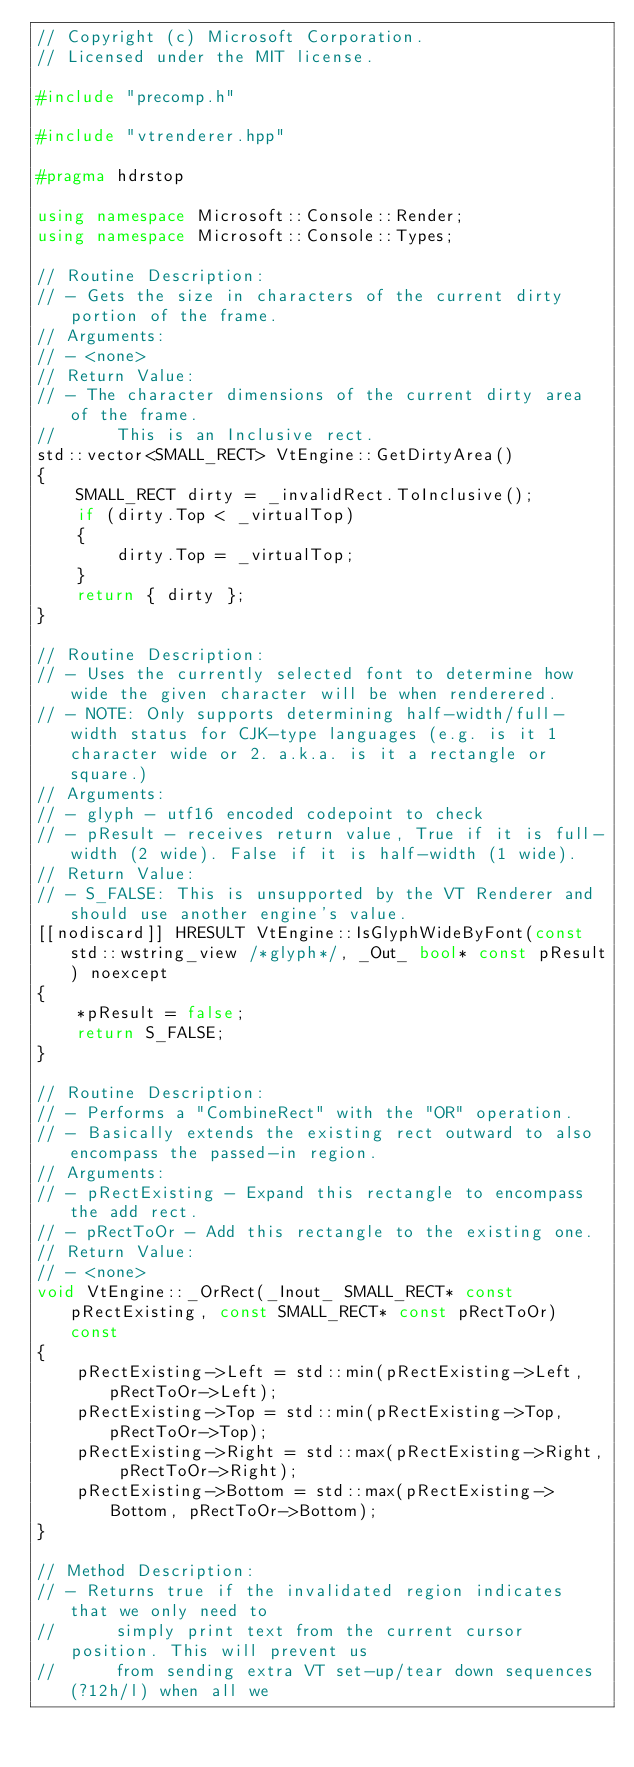<code> <loc_0><loc_0><loc_500><loc_500><_C++_>// Copyright (c) Microsoft Corporation.
// Licensed under the MIT license.

#include "precomp.h"

#include "vtrenderer.hpp"

#pragma hdrstop

using namespace Microsoft::Console::Render;
using namespace Microsoft::Console::Types;

// Routine Description:
// - Gets the size in characters of the current dirty portion of the frame.
// Arguments:
// - <none>
// Return Value:
// - The character dimensions of the current dirty area of the frame.
//      This is an Inclusive rect.
std::vector<SMALL_RECT> VtEngine::GetDirtyArea()
{
    SMALL_RECT dirty = _invalidRect.ToInclusive();
    if (dirty.Top < _virtualTop)
    {
        dirty.Top = _virtualTop;
    }
    return { dirty };
}

// Routine Description:
// - Uses the currently selected font to determine how wide the given character will be when renderered.
// - NOTE: Only supports determining half-width/full-width status for CJK-type languages (e.g. is it 1 character wide or 2. a.k.a. is it a rectangle or square.)
// Arguments:
// - glyph - utf16 encoded codepoint to check
// - pResult - receives return value, True if it is full-width (2 wide). False if it is half-width (1 wide).
// Return Value:
// - S_FALSE: This is unsupported by the VT Renderer and should use another engine's value.
[[nodiscard]] HRESULT VtEngine::IsGlyphWideByFont(const std::wstring_view /*glyph*/, _Out_ bool* const pResult) noexcept
{
    *pResult = false;
    return S_FALSE;
}

// Routine Description:
// - Performs a "CombineRect" with the "OR" operation.
// - Basically extends the existing rect outward to also encompass the passed-in region.
// Arguments:
// - pRectExisting - Expand this rectangle to encompass the add rect.
// - pRectToOr - Add this rectangle to the existing one.
// Return Value:
// - <none>
void VtEngine::_OrRect(_Inout_ SMALL_RECT* const pRectExisting, const SMALL_RECT* const pRectToOr) const
{
    pRectExisting->Left = std::min(pRectExisting->Left, pRectToOr->Left);
    pRectExisting->Top = std::min(pRectExisting->Top, pRectToOr->Top);
    pRectExisting->Right = std::max(pRectExisting->Right, pRectToOr->Right);
    pRectExisting->Bottom = std::max(pRectExisting->Bottom, pRectToOr->Bottom);
}

// Method Description:
// - Returns true if the invalidated region indicates that we only need to
//      simply print text from the current cursor position. This will prevent us
//      from sending extra VT set-up/tear down sequences (?12h/l) when all we</code> 